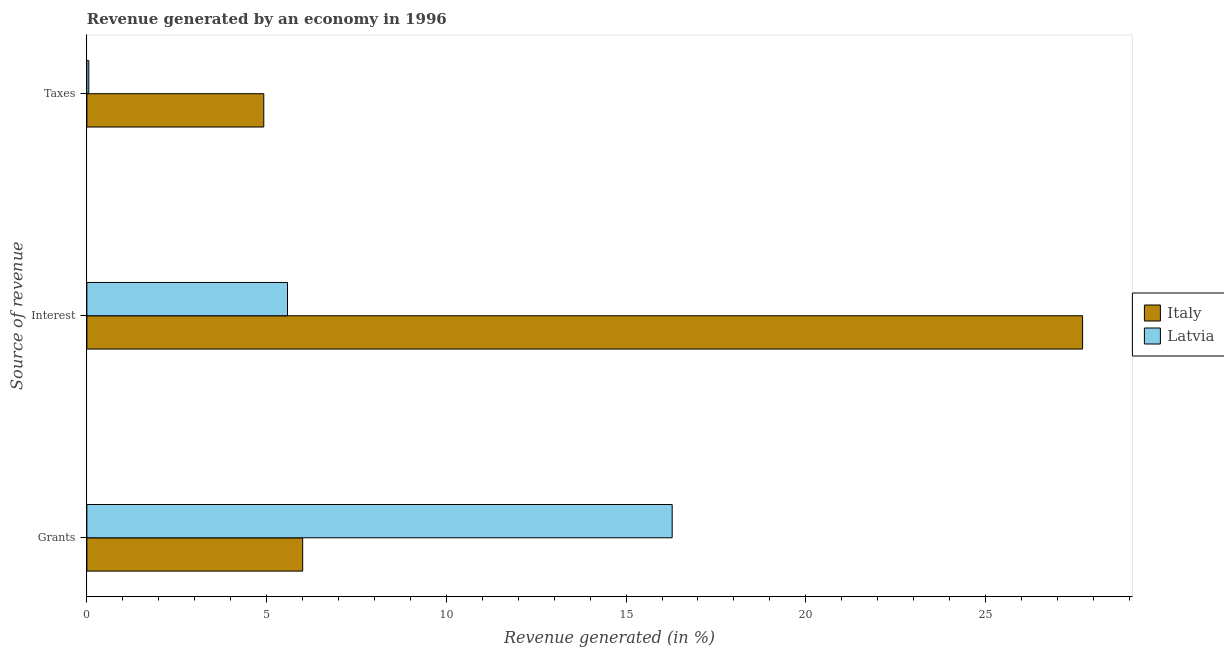How many different coloured bars are there?
Offer a very short reply. 2. Are the number of bars on each tick of the Y-axis equal?
Offer a very short reply. Yes. What is the label of the 2nd group of bars from the top?
Ensure brevity in your answer.  Interest. What is the percentage of revenue generated by interest in Italy?
Provide a succinct answer. 27.7. Across all countries, what is the maximum percentage of revenue generated by taxes?
Offer a terse response. 4.92. Across all countries, what is the minimum percentage of revenue generated by grants?
Offer a very short reply. 6. In which country was the percentage of revenue generated by grants maximum?
Your response must be concise. Latvia. What is the total percentage of revenue generated by taxes in the graph?
Ensure brevity in your answer.  4.97. What is the difference between the percentage of revenue generated by taxes in Latvia and that in Italy?
Keep it short and to the point. -4.87. What is the difference between the percentage of revenue generated by taxes in Italy and the percentage of revenue generated by interest in Latvia?
Give a very brief answer. -0.66. What is the average percentage of revenue generated by grants per country?
Offer a very short reply. 11.14. What is the difference between the percentage of revenue generated by grants and percentage of revenue generated by interest in Italy?
Provide a short and direct response. -21.7. In how many countries, is the percentage of revenue generated by taxes greater than 11 %?
Make the answer very short. 0. What is the ratio of the percentage of revenue generated by interest in Italy to that in Latvia?
Provide a short and direct response. 4.96. Is the percentage of revenue generated by grants in Latvia less than that in Italy?
Give a very brief answer. No. Is the difference between the percentage of revenue generated by interest in Latvia and Italy greater than the difference between the percentage of revenue generated by taxes in Latvia and Italy?
Your answer should be very brief. No. What is the difference between the highest and the second highest percentage of revenue generated by grants?
Make the answer very short. 10.28. What is the difference between the highest and the lowest percentage of revenue generated by interest?
Your answer should be very brief. 22.12. Is the sum of the percentage of revenue generated by interest in Italy and Latvia greater than the maximum percentage of revenue generated by taxes across all countries?
Ensure brevity in your answer.  Yes. What does the 1st bar from the top in Taxes represents?
Provide a succinct answer. Latvia. Is it the case that in every country, the sum of the percentage of revenue generated by grants and percentage of revenue generated by interest is greater than the percentage of revenue generated by taxes?
Your answer should be very brief. Yes. How many bars are there?
Provide a succinct answer. 6. Are all the bars in the graph horizontal?
Offer a terse response. Yes. How many countries are there in the graph?
Ensure brevity in your answer.  2. Are the values on the major ticks of X-axis written in scientific E-notation?
Offer a terse response. No. What is the title of the graph?
Ensure brevity in your answer.  Revenue generated by an economy in 1996. What is the label or title of the X-axis?
Give a very brief answer. Revenue generated (in %). What is the label or title of the Y-axis?
Your response must be concise. Source of revenue. What is the Revenue generated (in %) of Italy in Grants?
Offer a terse response. 6. What is the Revenue generated (in %) in Latvia in Grants?
Your response must be concise. 16.28. What is the Revenue generated (in %) of Italy in Interest?
Offer a terse response. 27.7. What is the Revenue generated (in %) of Latvia in Interest?
Keep it short and to the point. 5.58. What is the Revenue generated (in %) in Italy in Taxes?
Give a very brief answer. 4.92. What is the Revenue generated (in %) of Latvia in Taxes?
Make the answer very short. 0.05. Across all Source of revenue, what is the maximum Revenue generated (in %) in Italy?
Give a very brief answer. 27.7. Across all Source of revenue, what is the maximum Revenue generated (in %) in Latvia?
Give a very brief answer. 16.28. Across all Source of revenue, what is the minimum Revenue generated (in %) of Italy?
Offer a very short reply. 4.92. Across all Source of revenue, what is the minimum Revenue generated (in %) in Latvia?
Provide a succinct answer. 0.05. What is the total Revenue generated (in %) in Italy in the graph?
Offer a terse response. 38.62. What is the total Revenue generated (in %) of Latvia in the graph?
Your answer should be compact. 21.92. What is the difference between the Revenue generated (in %) of Italy in Grants and that in Interest?
Give a very brief answer. -21.7. What is the difference between the Revenue generated (in %) of Latvia in Grants and that in Interest?
Keep it short and to the point. 10.7. What is the difference between the Revenue generated (in %) in Italy in Grants and that in Taxes?
Ensure brevity in your answer.  1.08. What is the difference between the Revenue generated (in %) of Latvia in Grants and that in Taxes?
Offer a very short reply. 16.23. What is the difference between the Revenue generated (in %) of Italy in Interest and that in Taxes?
Your response must be concise. 22.78. What is the difference between the Revenue generated (in %) of Latvia in Interest and that in Taxes?
Make the answer very short. 5.53. What is the difference between the Revenue generated (in %) in Italy in Grants and the Revenue generated (in %) in Latvia in Interest?
Provide a succinct answer. 0.42. What is the difference between the Revenue generated (in %) in Italy in Grants and the Revenue generated (in %) in Latvia in Taxes?
Ensure brevity in your answer.  5.95. What is the difference between the Revenue generated (in %) in Italy in Interest and the Revenue generated (in %) in Latvia in Taxes?
Ensure brevity in your answer.  27.65. What is the average Revenue generated (in %) of Italy per Source of revenue?
Your response must be concise. 12.88. What is the average Revenue generated (in %) of Latvia per Source of revenue?
Make the answer very short. 7.31. What is the difference between the Revenue generated (in %) in Italy and Revenue generated (in %) in Latvia in Grants?
Offer a terse response. -10.28. What is the difference between the Revenue generated (in %) of Italy and Revenue generated (in %) of Latvia in Interest?
Provide a short and direct response. 22.12. What is the difference between the Revenue generated (in %) in Italy and Revenue generated (in %) in Latvia in Taxes?
Your answer should be very brief. 4.87. What is the ratio of the Revenue generated (in %) in Italy in Grants to that in Interest?
Offer a terse response. 0.22. What is the ratio of the Revenue generated (in %) in Latvia in Grants to that in Interest?
Give a very brief answer. 2.92. What is the ratio of the Revenue generated (in %) in Italy in Grants to that in Taxes?
Provide a succinct answer. 1.22. What is the ratio of the Revenue generated (in %) of Latvia in Grants to that in Taxes?
Your response must be concise. 304.71. What is the ratio of the Revenue generated (in %) of Italy in Interest to that in Taxes?
Offer a very short reply. 5.63. What is the ratio of the Revenue generated (in %) in Latvia in Interest to that in Taxes?
Offer a very short reply. 104.44. What is the difference between the highest and the second highest Revenue generated (in %) in Italy?
Your answer should be compact. 21.7. What is the difference between the highest and the second highest Revenue generated (in %) of Latvia?
Offer a terse response. 10.7. What is the difference between the highest and the lowest Revenue generated (in %) of Italy?
Ensure brevity in your answer.  22.78. What is the difference between the highest and the lowest Revenue generated (in %) in Latvia?
Your answer should be very brief. 16.23. 